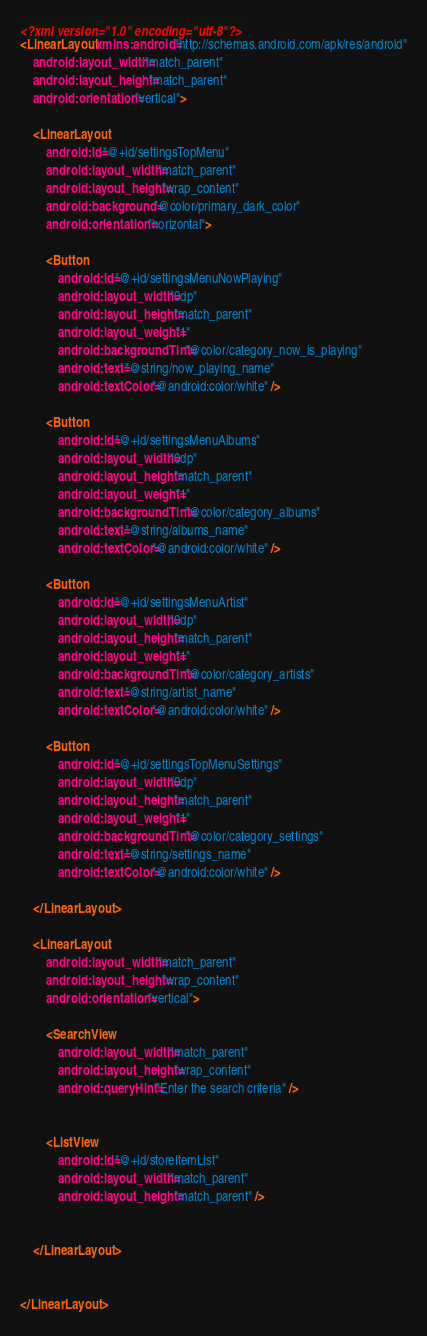<code> <loc_0><loc_0><loc_500><loc_500><_XML_><?xml version="1.0" encoding="utf-8"?>
<LinearLayout xmlns:android="http://schemas.android.com/apk/res/android"
    android:layout_width="match_parent"
    android:layout_height="match_parent"
    android:orientation="vertical">

    <LinearLayout
        android:id="@+id/settingsTopMenu"
        android:layout_width="match_parent"
        android:layout_height="wrap_content"
        android:background="@color/primary_dark_color"
        android:orientation="horizontal">

        <Button
            android:id="@+id/settingsMenuNowPlaying"
            android:layout_width="0dp"
            android:layout_height="match_parent"
            android:layout_weight="1"
            android:backgroundTint="@color/category_now_is_playing"
            android:text="@string/now_playing_name"
            android:textColor="@android:color/white" />

        <Button
            android:id="@+id/settingsMenuAlbums"
            android:layout_width="0dp"
            android:layout_height="match_parent"
            android:layout_weight="1"
            android:backgroundTint="@color/category_albums"
            android:text="@string/albums_name"
            android:textColor="@android:color/white" />

        <Button
            android:id="@+id/settingsMenuArtist"
            android:layout_width="0dp"
            android:layout_height="match_parent"
            android:layout_weight="1"
            android:backgroundTint="@color/category_artists"
            android:text="@string/artist_name"
            android:textColor="@android:color/white" />

        <Button
            android:id="@+id/settingsTopMenuSettings"
            android:layout_width="0dp"
            android:layout_height="match_parent"
            android:layout_weight="1"
            android:backgroundTint="@color/category_settings"
            android:text="@string/settings_name"
            android:textColor="@android:color/white" />

    </LinearLayout>

    <LinearLayout
        android:layout_width="match_parent"
        android:layout_height="wrap_content"
        android:orientation="vertical">

        <SearchView
            android:layout_width="match_parent"
            android:layout_height="wrap_content"
            android:queryHint="Enter the search criteria" />


        <ListView
            android:id="@+id/storeItemList"
            android:layout_width="match_parent"
            android:layout_height="match_parent" />


    </LinearLayout>


</LinearLayout>
</code> 